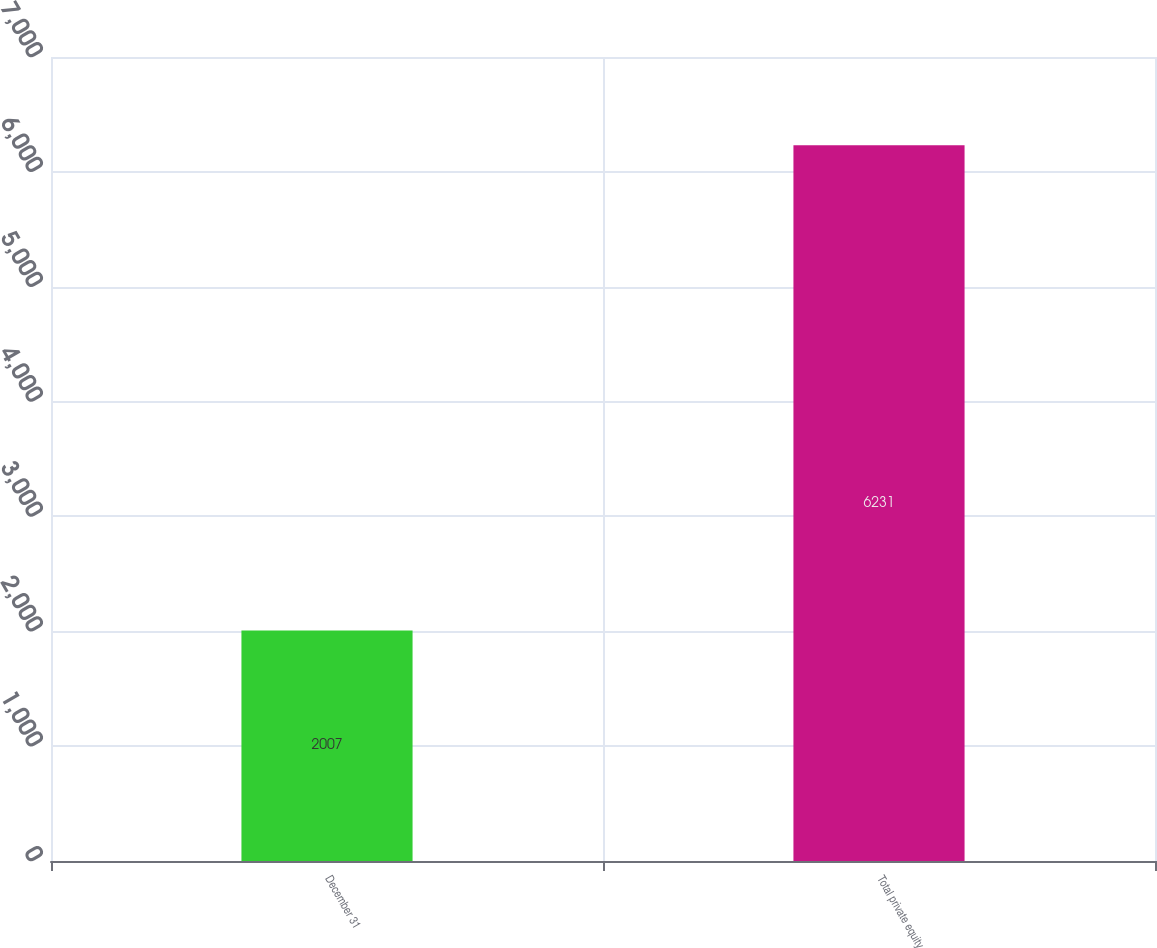Convert chart. <chart><loc_0><loc_0><loc_500><loc_500><bar_chart><fcel>December 31<fcel>Total private equity<nl><fcel>2007<fcel>6231<nl></chart> 